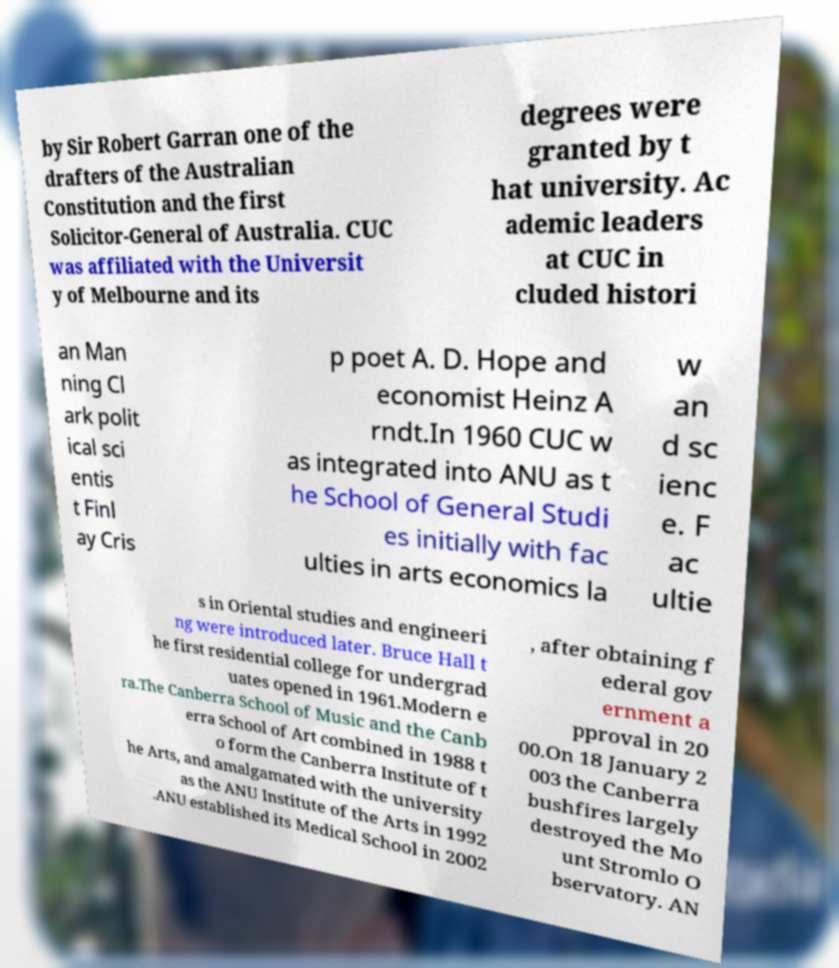Can you read and provide the text displayed in the image?This photo seems to have some interesting text. Can you extract and type it out for me? by Sir Robert Garran one of the drafters of the Australian Constitution and the first Solicitor-General of Australia. CUC was affiliated with the Universit y of Melbourne and its degrees were granted by t hat university. Ac ademic leaders at CUC in cluded histori an Man ning Cl ark polit ical sci entis t Finl ay Cris p poet A. D. Hope and economist Heinz A rndt.In 1960 CUC w as integrated into ANU as t he School of General Studi es initially with fac ulties in arts economics la w an d sc ienc e. F ac ultie s in Oriental studies and engineeri ng were introduced later. Bruce Hall t he first residential college for undergrad uates opened in 1961.Modern e ra.The Canberra School of Music and the Canb erra School of Art combined in 1988 t o form the Canberra Institute of t he Arts, and amalgamated with the university as the ANU Institute of the Arts in 1992 .ANU established its Medical School in 2002 , after obtaining f ederal gov ernment a pproval in 20 00.On 18 January 2 003 the Canberra bushfires largely destroyed the Mo unt Stromlo O bservatory. AN 